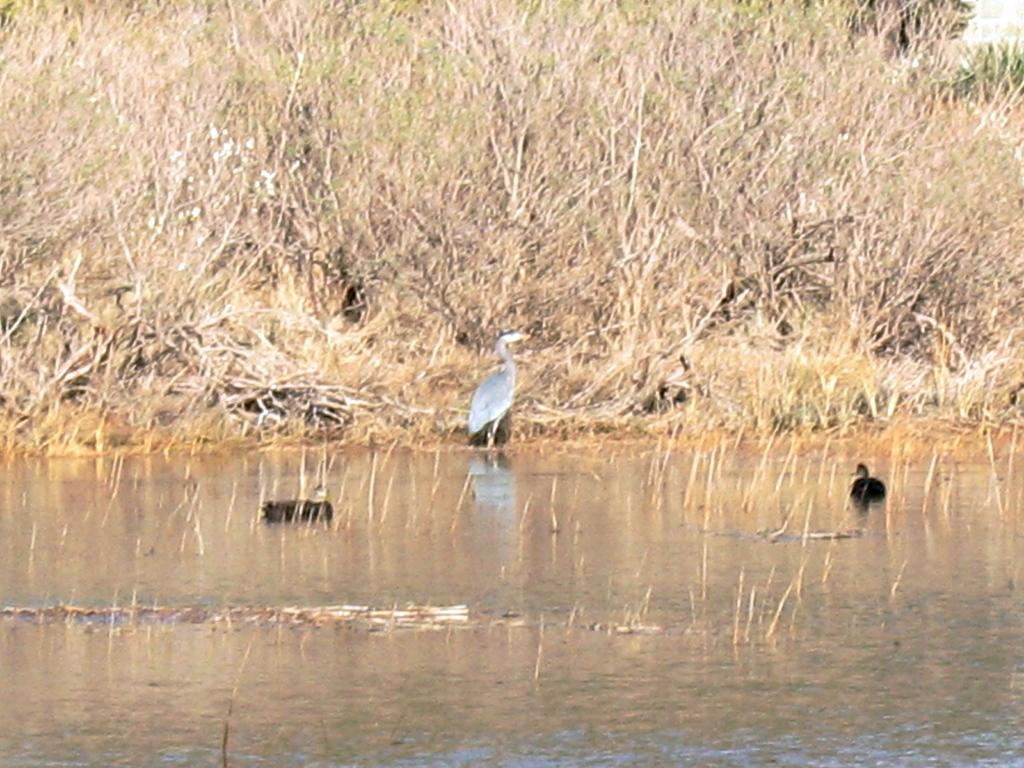What type of vegetation is present in the image? There is grass in the image. What animal can be seen standing on the ground in the image? There is a crane standing on the ground in the image. What type of birds are on the water in the image? There are ducks on the water in the image. Where is the pocket located in the image? There is no pocket present in the image. What type of home can be seen in the background of the image? There is no home visible in the image; it features grass, a crane, and ducks on water. 